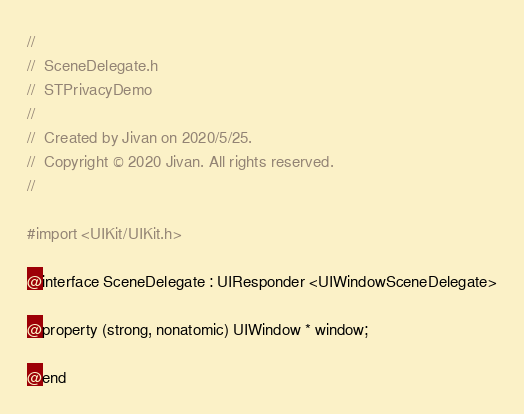Convert code to text. <code><loc_0><loc_0><loc_500><loc_500><_C_>//
//  SceneDelegate.h
//  STPrivacyDemo
//
//  Created by Jivan on 2020/5/25.
//  Copyright © 2020 Jivan. All rights reserved.
//

#import <UIKit/UIKit.h>

@interface SceneDelegate : UIResponder <UIWindowSceneDelegate>

@property (strong, nonatomic) UIWindow * window;

@end

</code> 